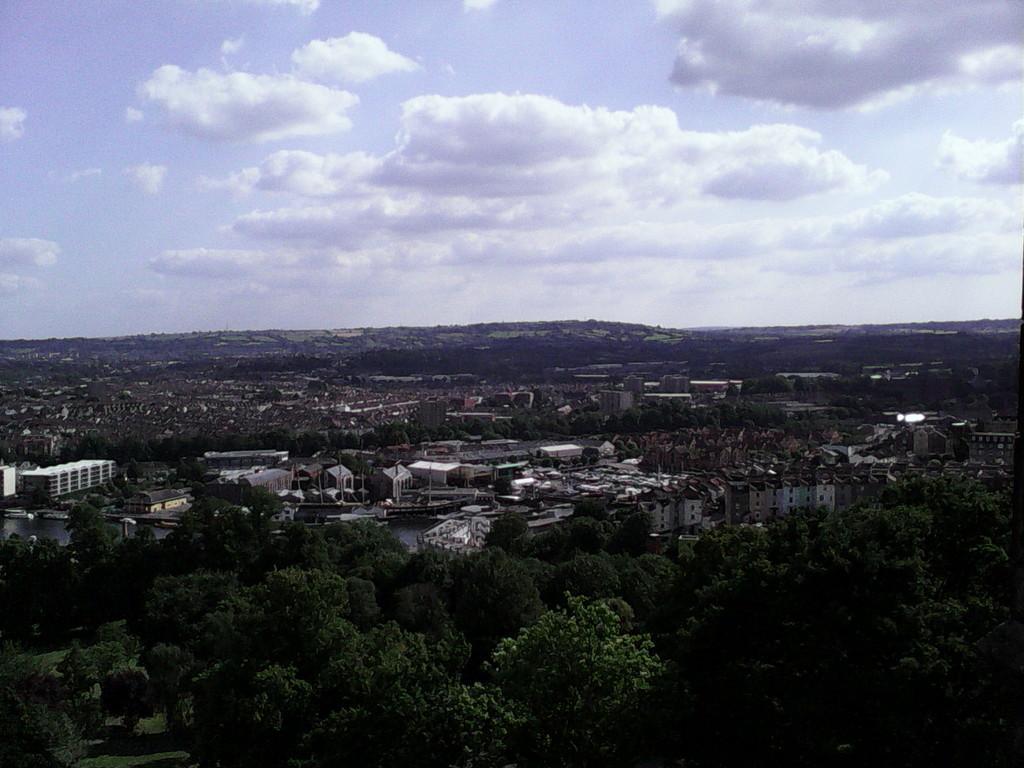How would you summarize this image in a sentence or two? In this image we can see many trees and buildings. In the background there is sky with clouds. 